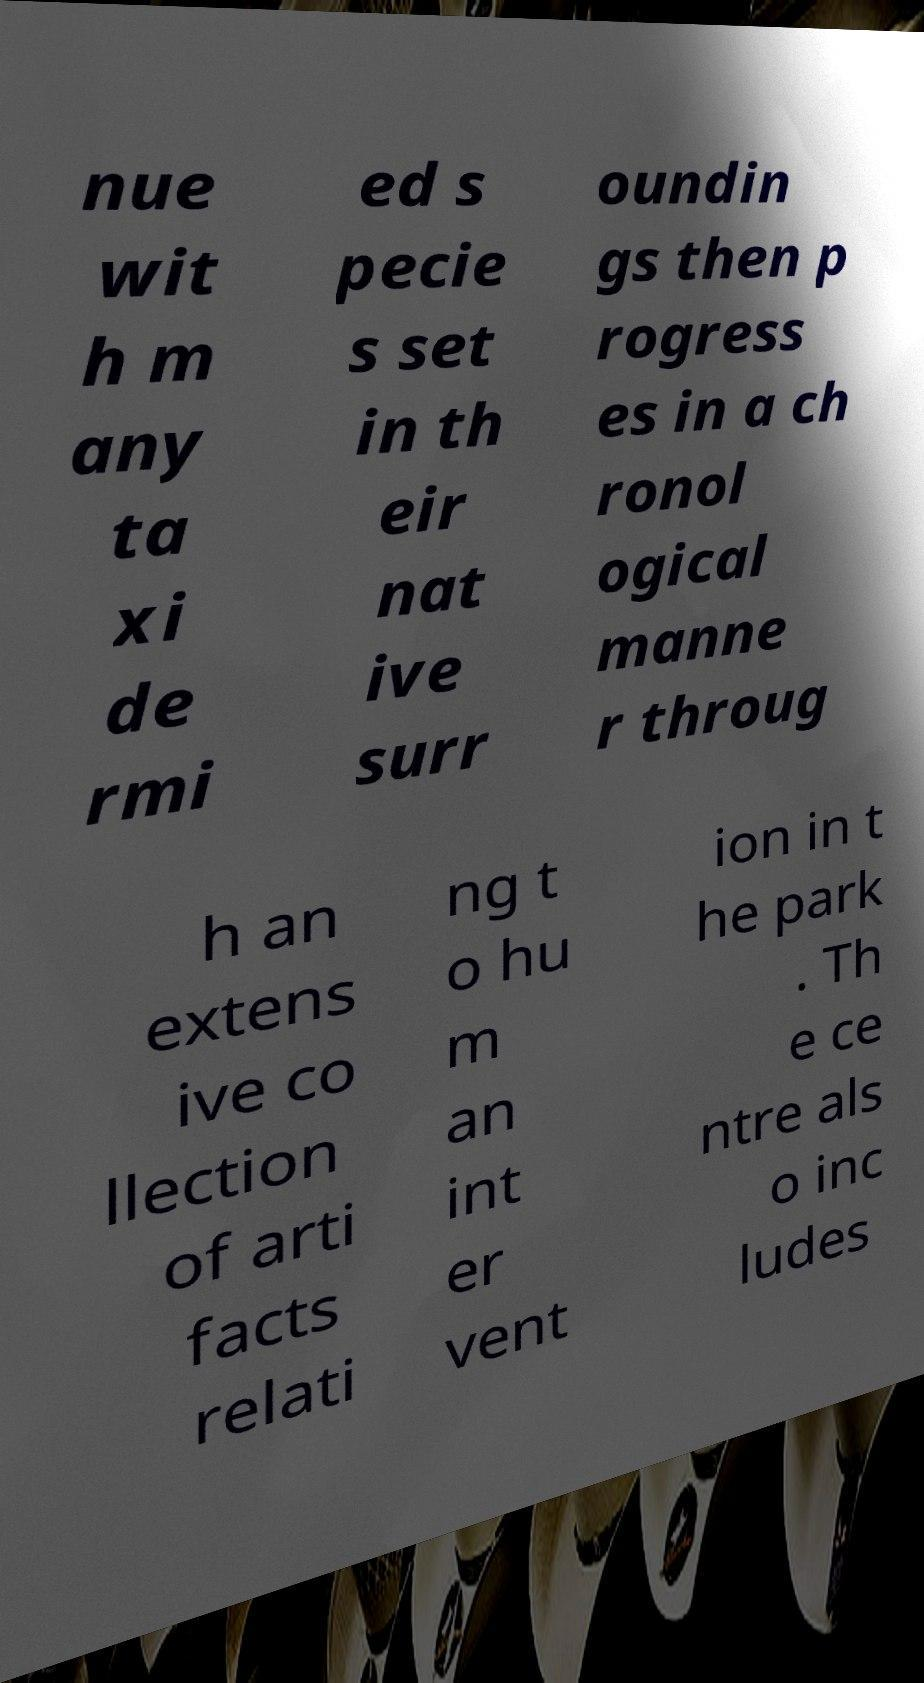Can you accurately transcribe the text from the provided image for me? nue wit h m any ta xi de rmi ed s pecie s set in th eir nat ive surr oundin gs then p rogress es in a ch ronol ogical manne r throug h an extens ive co llection of arti facts relati ng t o hu m an int er vent ion in t he park . Th e ce ntre als o inc ludes 